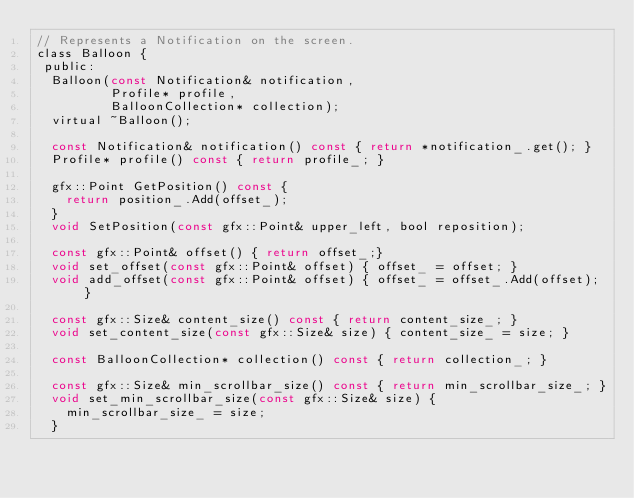Convert code to text. <code><loc_0><loc_0><loc_500><loc_500><_C_>// Represents a Notification on the screen.
class Balloon {
 public:
  Balloon(const Notification& notification,
          Profile* profile,
          BalloonCollection* collection);
  virtual ~Balloon();

  const Notification& notification() const { return *notification_.get(); }
  Profile* profile() const { return profile_; }

  gfx::Point GetPosition() const {
    return position_.Add(offset_);
  }
  void SetPosition(const gfx::Point& upper_left, bool reposition);

  const gfx::Point& offset() { return offset_;}
  void set_offset(const gfx::Point& offset) { offset_ = offset; }
  void add_offset(const gfx::Point& offset) { offset_ = offset_.Add(offset); }

  const gfx::Size& content_size() const { return content_size_; }
  void set_content_size(const gfx::Size& size) { content_size_ = size; }

  const BalloonCollection* collection() const { return collection_; }

  const gfx::Size& min_scrollbar_size() const { return min_scrollbar_size_; }
  void set_min_scrollbar_size(const gfx::Size& size) {
    min_scrollbar_size_ = size;
  }
</code> 